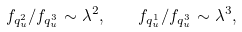<formula> <loc_0><loc_0><loc_500><loc_500>f _ { q _ { u } ^ { 2 } } / f _ { q _ { u } ^ { 3 } } \sim \lambda ^ { 2 } , \quad f _ { q _ { u } ^ { 1 } } / f _ { q _ { u } ^ { 3 } } \sim \lambda ^ { 3 } ,</formula> 